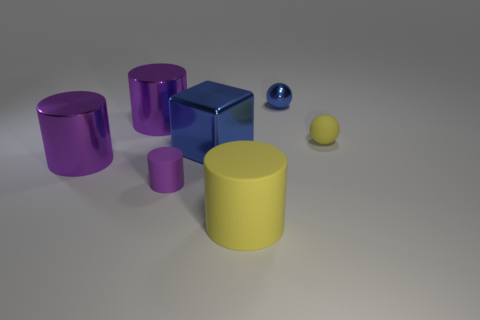Subtract all small rubber cylinders. How many cylinders are left? 3 Add 1 small yellow rubber blocks. How many objects exist? 8 Subtract all blue balls. How many balls are left? 1 Subtract all cylinders. How many objects are left? 3 Subtract 0 brown spheres. How many objects are left? 7 Subtract 1 balls. How many balls are left? 1 Subtract all yellow balls. Subtract all yellow cylinders. How many balls are left? 1 Subtract all purple cylinders. How many yellow balls are left? 1 Subtract all small green matte cylinders. Subtract all tiny rubber things. How many objects are left? 5 Add 4 cylinders. How many cylinders are left? 8 